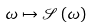Convert formula to latex. <formula><loc_0><loc_0><loc_500><loc_500>\omega \mapsto \mathcal { S } \left ( \omega \right )</formula> 